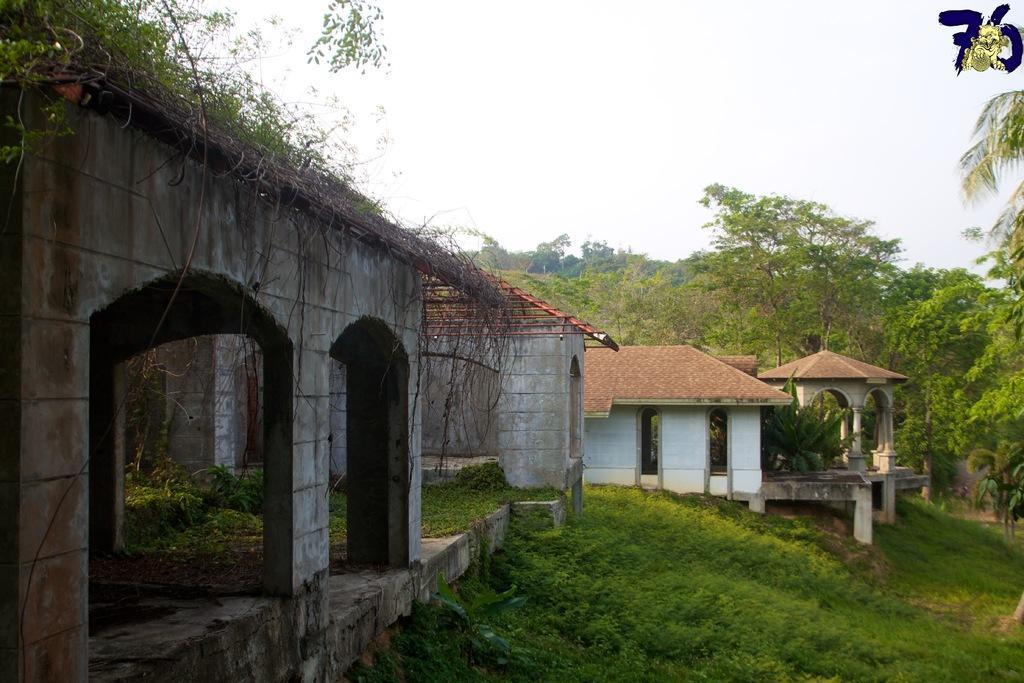In one or two sentences, can you explain what this image depicts? In this picture, we see houses with red color roof. At the bottom of the picture, we see grass. There are many trees in the background. At the top of the picture, we see the sky. 